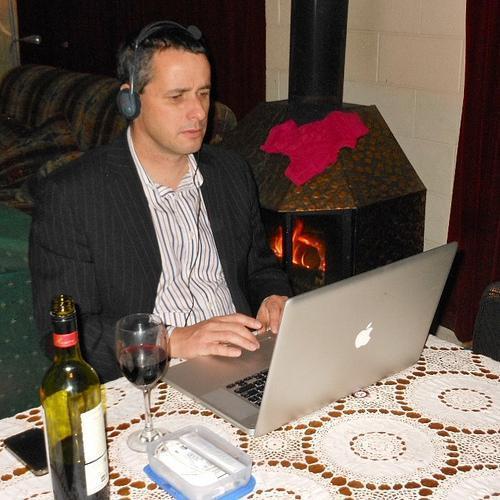How many wine bottles are visible?
Give a very brief answer. 1. 